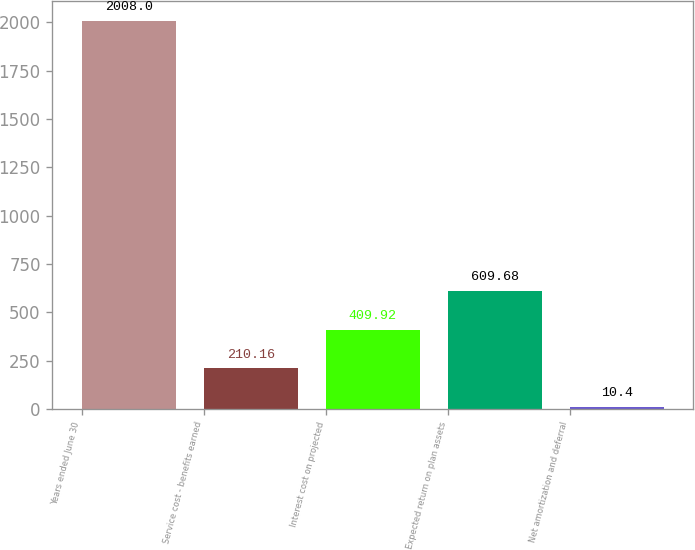<chart> <loc_0><loc_0><loc_500><loc_500><bar_chart><fcel>Years ended June 30<fcel>Service cost - benefits earned<fcel>Interest cost on projected<fcel>Expected return on plan assets<fcel>Net amortization and deferral<nl><fcel>2008<fcel>210.16<fcel>409.92<fcel>609.68<fcel>10.4<nl></chart> 